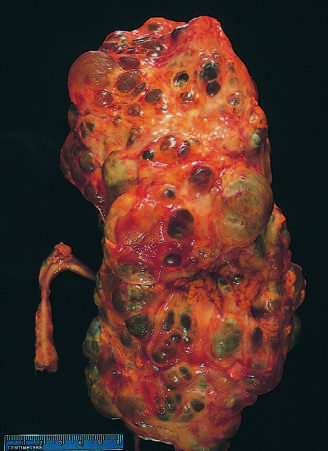what is markedly enlarged?
Answer the question using a single word or phrase. The kidney 